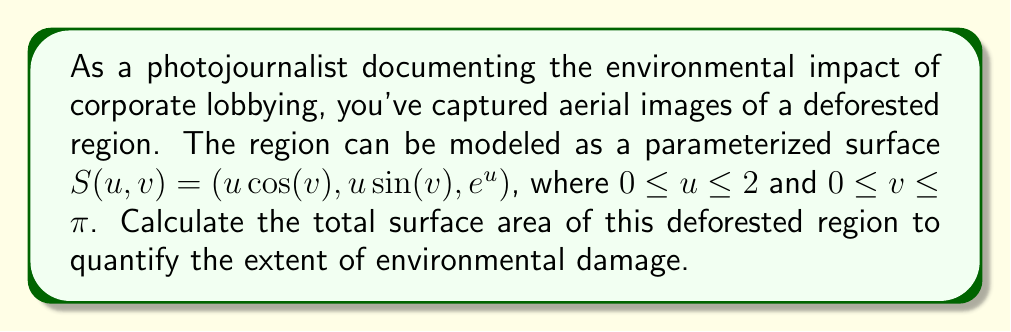Teach me how to tackle this problem. To find the surface area, we need to use the surface integral formula:

$$A = \int\int_D \left\|\frac{\partial S}{\partial u} \times \frac{\partial S}{\partial v}\right\| dudv$$

Step 1: Calculate partial derivatives
$$\frac{\partial S}{\partial u} = (\cos(v), \sin(v), e^u)$$
$$\frac{\partial S}{\partial v} = (-u\sin(v), u\cos(v), 0)$$

Step 2: Compute the cross product
$$\frac{\partial S}{\partial u} \times \frac{\partial S}{\partial v} = (ue^u\cos(v), ue^u\sin(v), u)$$

Step 3: Calculate the magnitude of the cross product
$$\left\|\frac{\partial S}{\partial u} \times \frac{\partial S}{\partial v}\right\| = \sqrt{u^2e^{2u}\cos^2(v) + u^2e^{2u}\sin^2(v) + u^2}$$
$$= \sqrt{u^2e^{2u}(\cos^2(v) + \sin^2(v)) + u^2} = \sqrt{u^2e^{2u} + u^2} = u\sqrt{e^{2u} + 1}$$

Step 4: Set up the double integral
$$A = \int_0^2 \int_0^\pi u\sqrt{e^{2u} + 1} dvdu$$

Step 5: Evaluate the inner integral with respect to v
$$A = \int_0^2 \pi u\sqrt{e^{2u} + 1} du$$

Step 6: Evaluate the outer integral with respect to u
Let $w = e^{2u} + 1$, then $dw = 2e^{2u}du$ and $u = \frac{1}{2}\ln(w-1)$

$$A = \frac{\pi}{4} \int_2^{e^4+1} \ln(w-1)\sqrt{w} \frac{dw}{w-1}$$

This integral doesn't have a closed-form solution, so we need to evaluate it numerically.

Using numerical integration methods, we find:

$$A \approx 36.73 \text{ square units}$$
Answer: $36.73 \text{ square units}$ 